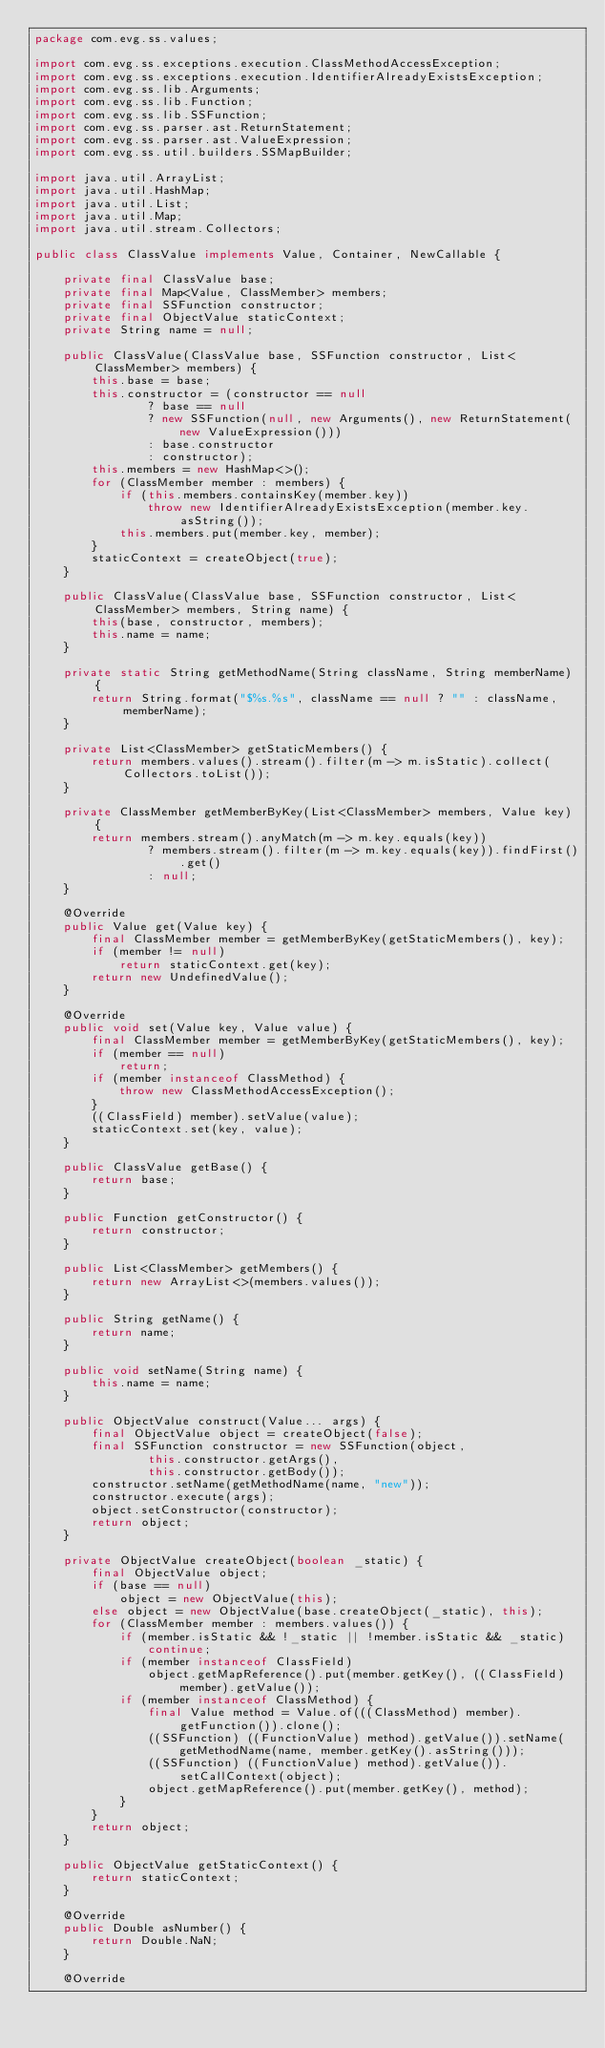<code> <loc_0><loc_0><loc_500><loc_500><_Java_>package com.evg.ss.values;

import com.evg.ss.exceptions.execution.ClassMethodAccessException;
import com.evg.ss.exceptions.execution.IdentifierAlreadyExistsException;
import com.evg.ss.lib.Arguments;
import com.evg.ss.lib.Function;
import com.evg.ss.lib.SSFunction;
import com.evg.ss.parser.ast.ReturnStatement;
import com.evg.ss.parser.ast.ValueExpression;
import com.evg.ss.util.builders.SSMapBuilder;

import java.util.ArrayList;
import java.util.HashMap;
import java.util.List;
import java.util.Map;
import java.util.stream.Collectors;

public class ClassValue implements Value, Container, NewCallable {

    private final ClassValue base;
    private final Map<Value, ClassMember> members;
    private final SSFunction constructor;
    private final ObjectValue staticContext;
    private String name = null;

    public ClassValue(ClassValue base, SSFunction constructor, List<ClassMember> members) {
        this.base = base;
        this.constructor = (constructor == null
                ? base == null
                ? new SSFunction(null, new Arguments(), new ReturnStatement(new ValueExpression()))
                : base.constructor
                : constructor);
        this.members = new HashMap<>();
        for (ClassMember member : members) {
            if (this.members.containsKey(member.key))
                throw new IdentifierAlreadyExistsException(member.key.asString());
            this.members.put(member.key, member);
        }
        staticContext = createObject(true);
    }

    public ClassValue(ClassValue base, SSFunction constructor, List<ClassMember> members, String name) {
        this(base, constructor, members);
        this.name = name;
    }

    private static String getMethodName(String className, String memberName) {
        return String.format("$%s.%s", className == null ? "" : className, memberName);
    }

    private List<ClassMember> getStaticMembers() {
        return members.values().stream().filter(m -> m.isStatic).collect(Collectors.toList());
    }

    private ClassMember getMemberByKey(List<ClassMember> members, Value key) {
        return members.stream().anyMatch(m -> m.key.equals(key))
                ? members.stream().filter(m -> m.key.equals(key)).findFirst().get()
                : null;
    }

    @Override
    public Value get(Value key) {
        final ClassMember member = getMemberByKey(getStaticMembers(), key);
        if (member != null)
            return staticContext.get(key);
        return new UndefinedValue();
    }

    @Override
    public void set(Value key, Value value) {
        final ClassMember member = getMemberByKey(getStaticMembers(), key);
        if (member == null)
            return;
        if (member instanceof ClassMethod) {
            throw new ClassMethodAccessException();
        }
        ((ClassField) member).setValue(value);
        staticContext.set(key, value);
    }

    public ClassValue getBase() {
        return base;
    }

    public Function getConstructor() {
        return constructor;
    }

    public List<ClassMember> getMembers() {
        return new ArrayList<>(members.values());
    }

    public String getName() {
        return name;
    }

    public void setName(String name) {
        this.name = name;
    }

    public ObjectValue construct(Value... args) {
        final ObjectValue object = createObject(false);
        final SSFunction constructor = new SSFunction(object,
                this.constructor.getArgs(),
                this.constructor.getBody());
        constructor.setName(getMethodName(name, "new"));
        constructor.execute(args);
        object.setConstructor(constructor);
        return object;
    }

    private ObjectValue createObject(boolean _static) {
        final ObjectValue object;
        if (base == null)
            object = new ObjectValue(this);
        else object = new ObjectValue(base.createObject(_static), this);
        for (ClassMember member : members.values()) {
            if (member.isStatic && !_static || !member.isStatic && _static)
                continue;
            if (member instanceof ClassField)
                object.getMapReference().put(member.getKey(), ((ClassField) member).getValue());
            if (member instanceof ClassMethod) {
                final Value method = Value.of(((ClassMethod) member).getFunction()).clone();
                ((SSFunction) ((FunctionValue) method).getValue()).setName(getMethodName(name, member.getKey().asString()));
                ((SSFunction) ((FunctionValue) method).getValue()).setCallContext(object);
                object.getMapReference().put(member.getKey(), method);
            }
        }
        return object;
    }

    public ObjectValue getStaticContext() {
        return staticContext;
    }

    @Override
    public Double asNumber() {
        return Double.NaN;
    }

    @Override</code> 